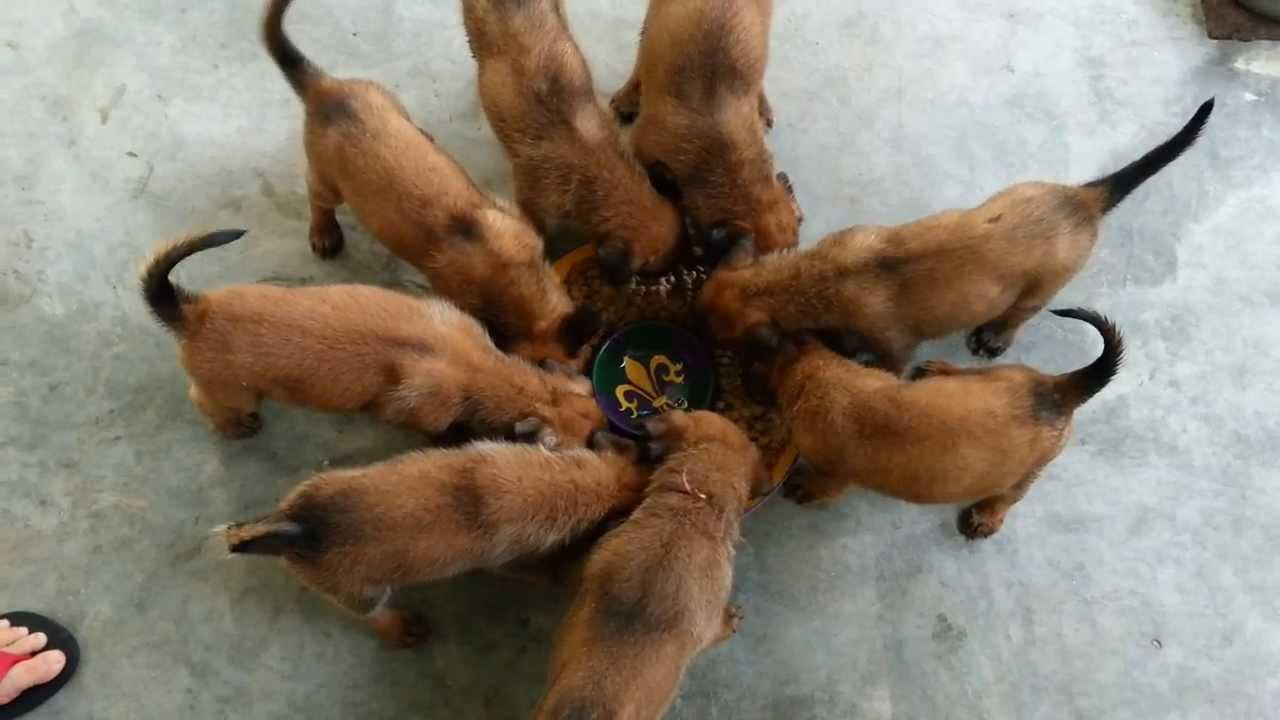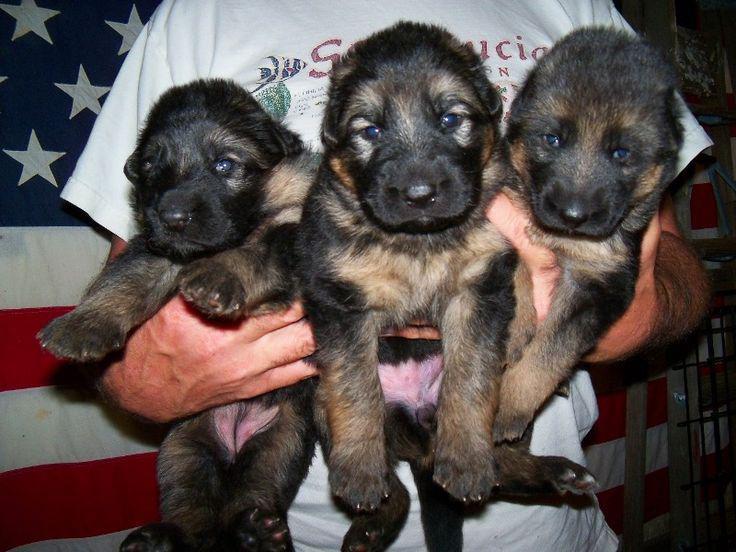The first image is the image on the left, the second image is the image on the right. Analyze the images presented: Is the assertion "An image shows puppies in collars on a blanket, with their heads aimed toward the middle of the group." valid? Answer yes or no. No. The first image is the image on the left, the second image is the image on the right. For the images shown, is this caption "There's no more than five dogs in the right image." true? Answer yes or no. Yes. 